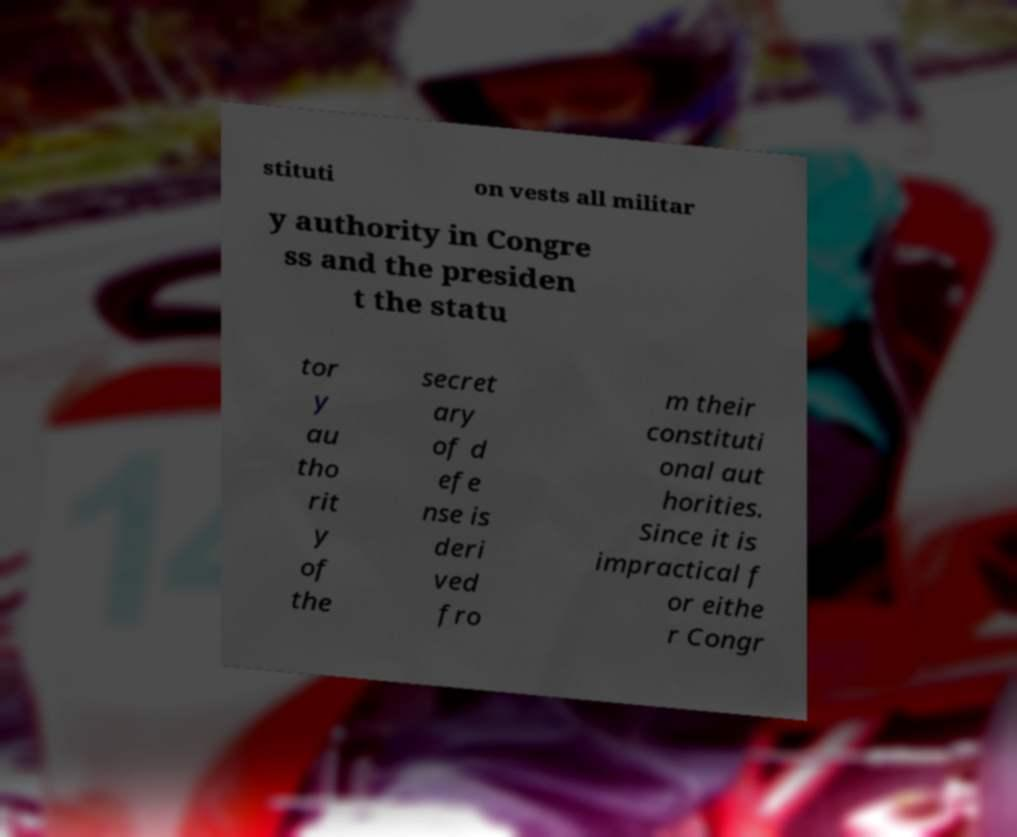Could you assist in decoding the text presented in this image and type it out clearly? stituti on vests all militar y authority in Congre ss and the presiden t the statu tor y au tho rit y of the secret ary of d efe nse is deri ved fro m their constituti onal aut horities. Since it is impractical f or eithe r Congr 